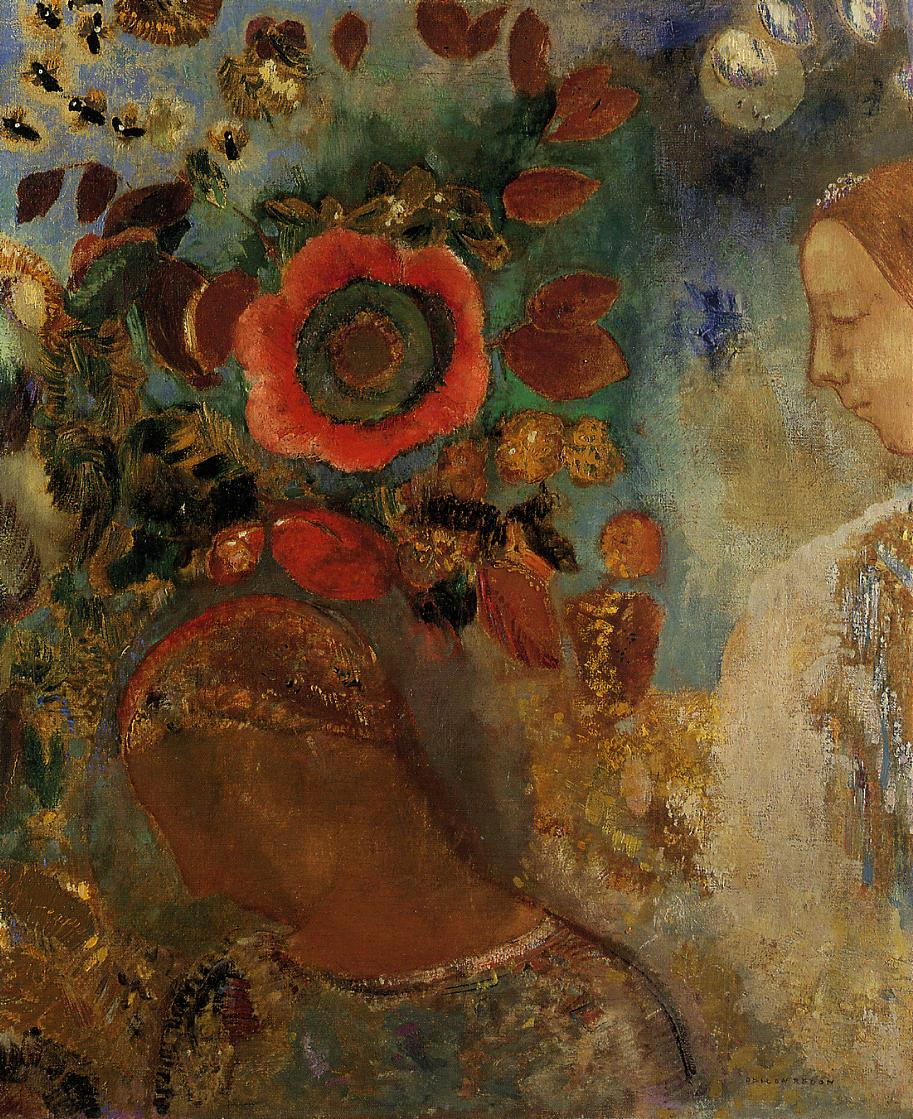Can you describe the main features of this image for me? The painting features a woman in profile surrounded by a vivid and colorful floral background. The focus is on her peaceful expression, which is softly rendered to capture a serene, almost contemplative mood. Her attire and the contours of her face blend seamlessly into the lush, vibrant surroundings, emphasizing a harmony between the human figure and nature. The backdrop is dominated by bold blooms, particularly a large, radiant red flower which draws the eye due to its size and central placement. Surrounding leaves and flowers are depicted in a mix of warm and cool tones, with dynamic brushstrokes characteristic of an impressionistic approach, creating a lively yet soothing atmosphere. The artwork could represent themes of nature's engulfing beauty, human introspection, or the intertwining of life and art, expressed through the fluidity and energy of the brushwork. 